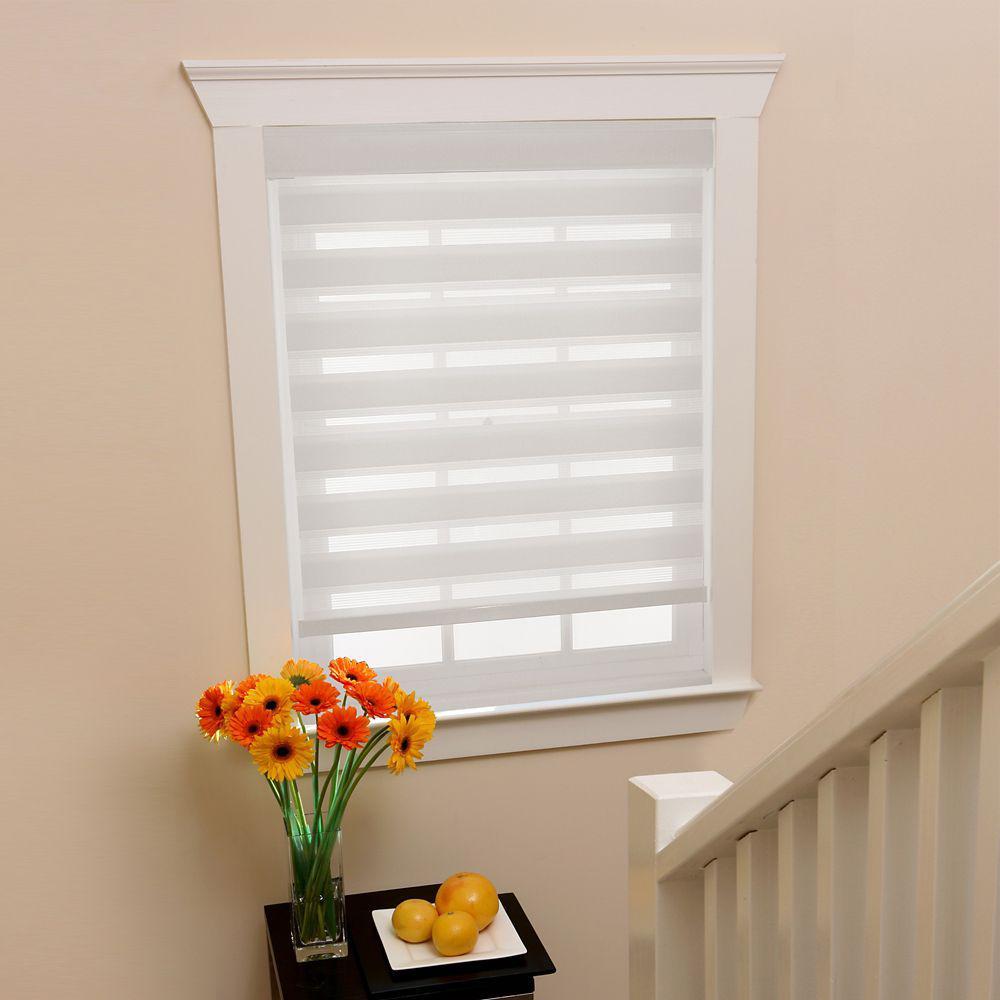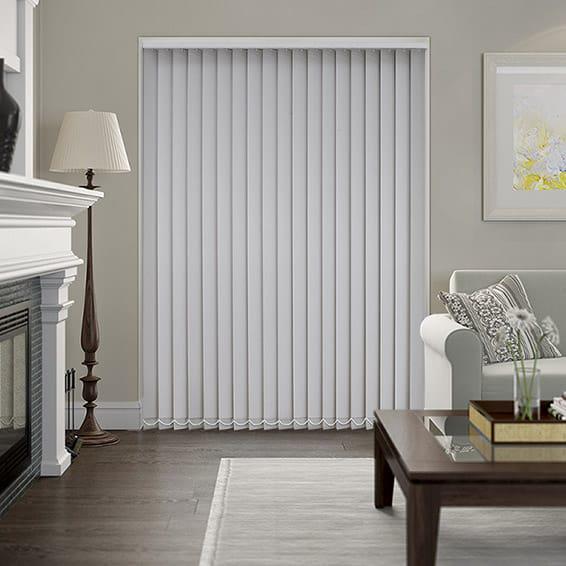The first image is the image on the left, the second image is the image on the right. For the images shown, is this caption "An image shows a tufted chair on the left in front of side-by-side windows with shades that are not fully closed." true? Answer yes or no. No. 